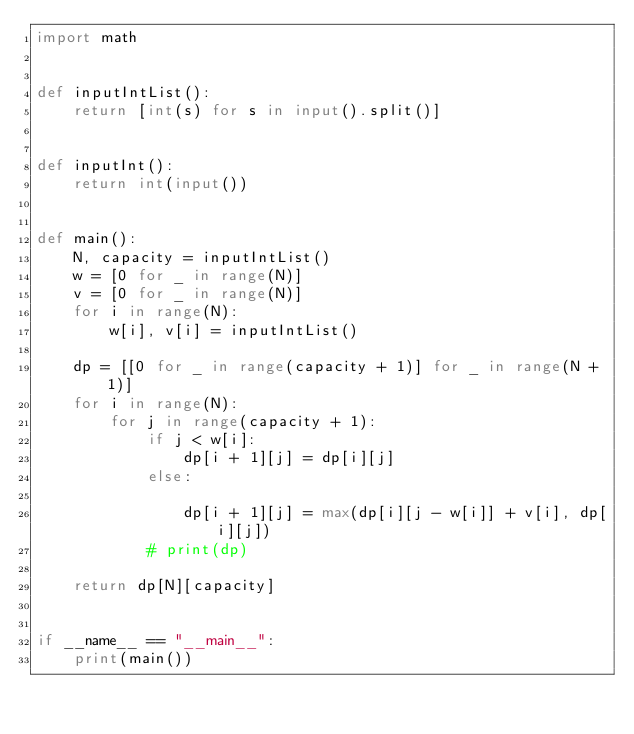<code> <loc_0><loc_0><loc_500><loc_500><_Python_>import math


def inputIntList():
    return [int(s) for s in input().split()]


def inputInt():
    return int(input())


def main():
    N, capacity = inputIntList()
    w = [0 for _ in range(N)]
    v = [0 for _ in range(N)]
    for i in range(N):
        w[i], v[i] = inputIntList()

    dp = [[0 for _ in range(capacity + 1)] for _ in range(N + 1)]
    for i in range(N):
        for j in range(capacity + 1):
            if j < w[i]:
                dp[i + 1][j] = dp[i][j]
            else:

                dp[i + 1][j] = max(dp[i][j - w[i]] + v[i], dp[i][j])
            # print(dp)

    return dp[N][capacity]


if __name__ == "__main__":
    print(main())
</code> 